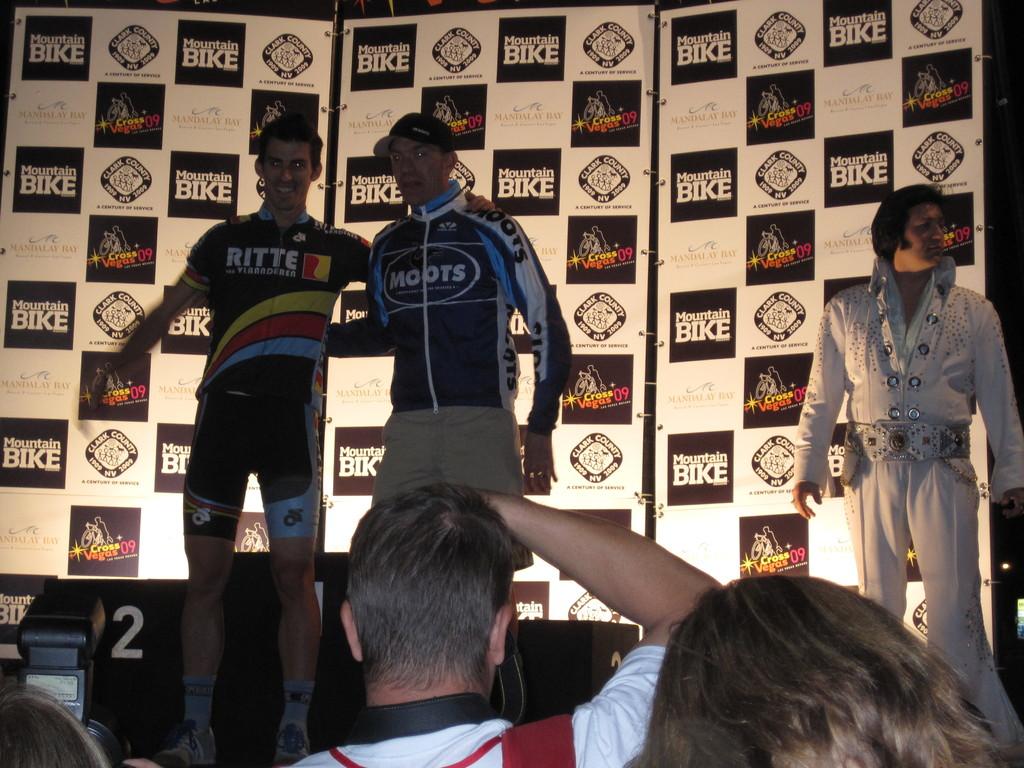What county is advertised in the background?
Your answer should be compact. Clark. 